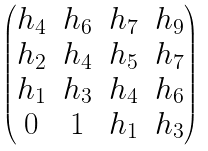Convert formula to latex. <formula><loc_0><loc_0><loc_500><loc_500>\begin{pmatrix} h _ { 4 } & h _ { 6 } & h _ { 7 } & h _ { 9 } \\ h _ { 2 } & h _ { 4 } & h _ { 5 } & h _ { 7 } \\ h _ { 1 } & h _ { 3 } & h _ { 4 } & h _ { 6 } \\ 0 & 1 & h _ { 1 } & h _ { 3 } \end{pmatrix}</formula> 